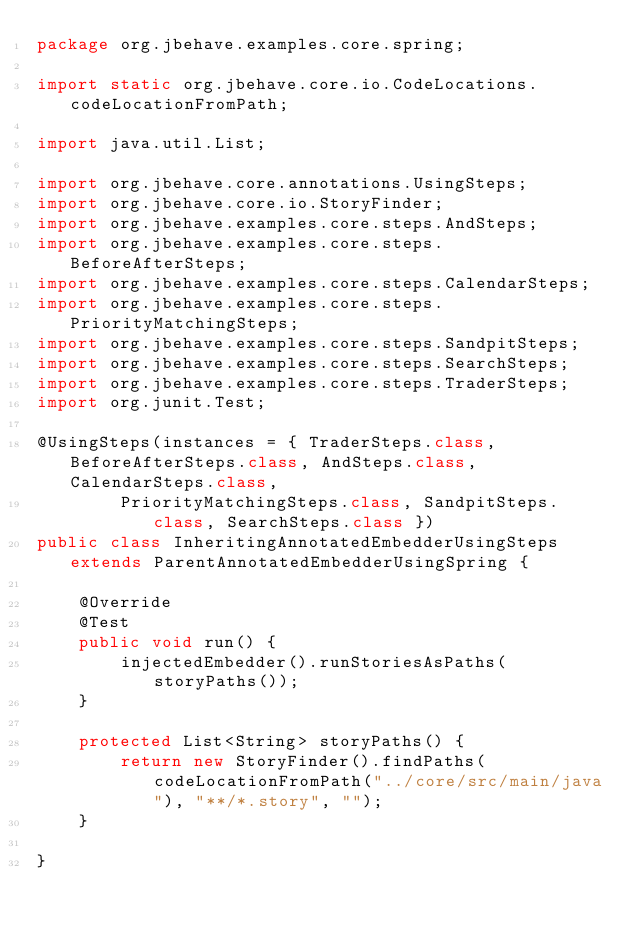Convert code to text. <code><loc_0><loc_0><loc_500><loc_500><_Java_>package org.jbehave.examples.core.spring;

import static org.jbehave.core.io.CodeLocations.codeLocationFromPath;

import java.util.List;

import org.jbehave.core.annotations.UsingSteps;
import org.jbehave.core.io.StoryFinder;
import org.jbehave.examples.core.steps.AndSteps;
import org.jbehave.examples.core.steps.BeforeAfterSteps;
import org.jbehave.examples.core.steps.CalendarSteps;
import org.jbehave.examples.core.steps.PriorityMatchingSteps;
import org.jbehave.examples.core.steps.SandpitSteps;
import org.jbehave.examples.core.steps.SearchSteps;
import org.jbehave.examples.core.steps.TraderSteps;
import org.junit.Test;

@UsingSteps(instances = { TraderSteps.class, BeforeAfterSteps.class, AndSteps.class, CalendarSteps.class,
        PriorityMatchingSteps.class, SandpitSteps.class, SearchSteps.class })
public class InheritingAnnotatedEmbedderUsingSteps extends ParentAnnotatedEmbedderUsingSpring {

    @Override
    @Test
    public void run() {
        injectedEmbedder().runStoriesAsPaths(storyPaths());
    }

    protected List<String> storyPaths() {
        return new StoryFinder().findPaths(codeLocationFromPath("../core/src/main/java"), "**/*.story", "");
    }

}
</code> 